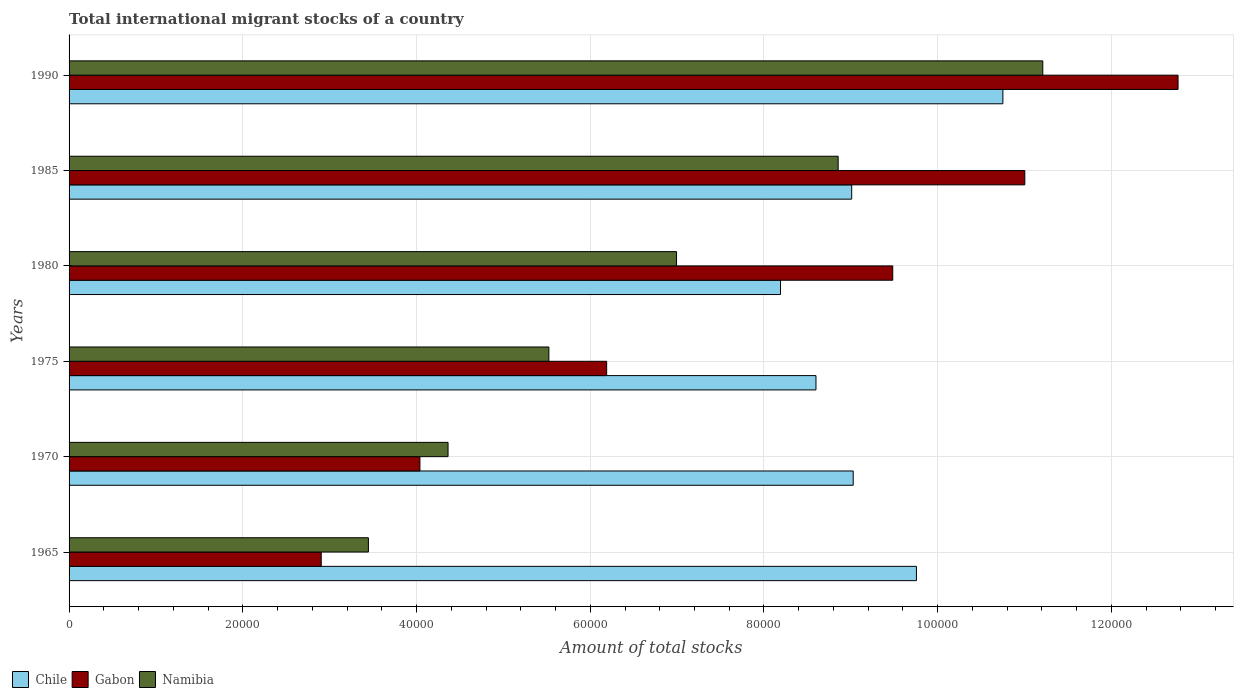How many different coloured bars are there?
Ensure brevity in your answer.  3. How many groups of bars are there?
Give a very brief answer. 6. Are the number of bars on each tick of the Y-axis equal?
Give a very brief answer. Yes. How many bars are there on the 2nd tick from the bottom?
Offer a terse response. 3. What is the label of the 4th group of bars from the top?
Make the answer very short. 1975. What is the amount of total stocks in in Chile in 1980?
Ensure brevity in your answer.  8.19e+04. Across all years, what is the maximum amount of total stocks in in Chile?
Your answer should be compact. 1.08e+05. Across all years, what is the minimum amount of total stocks in in Chile?
Ensure brevity in your answer.  8.19e+04. In which year was the amount of total stocks in in Namibia minimum?
Ensure brevity in your answer.  1965. What is the total amount of total stocks in in Namibia in the graph?
Ensure brevity in your answer.  4.04e+05. What is the difference between the amount of total stocks in in Namibia in 1970 and that in 1980?
Keep it short and to the point. -2.63e+04. What is the difference between the amount of total stocks in in Gabon in 1980 and the amount of total stocks in in Chile in 1985?
Ensure brevity in your answer.  4728. What is the average amount of total stocks in in Gabon per year?
Offer a very short reply. 7.73e+04. In the year 1970, what is the difference between the amount of total stocks in in Namibia and amount of total stocks in in Chile?
Your answer should be compact. -4.66e+04. What is the ratio of the amount of total stocks in in Namibia in 1965 to that in 1980?
Provide a succinct answer. 0.49. Is the amount of total stocks in in Namibia in 1970 less than that in 1975?
Keep it short and to the point. Yes. Is the difference between the amount of total stocks in in Namibia in 1975 and 1990 greater than the difference between the amount of total stocks in in Chile in 1975 and 1990?
Your response must be concise. No. What is the difference between the highest and the second highest amount of total stocks in in Chile?
Your answer should be very brief. 9950. What is the difference between the highest and the lowest amount of total stocks in in Gabon?
Offer a terse response. 9.86e+04. Is the sum of the amount of total stocks in in Chile in 1970 and 1975 greater than the maximum amount of total stocks in in Namibia across all years?
Offer a terse response. Yes. What does the 2nd bar from the top in 1970 represents?
Ensure brevity in your answer.  Gabon. Is it the case that in every year, the sum of the amount of total stocks in in Namibia and amount of total stocks in in Chile is greater than the amount of total stocks in in Gabon?
Offer a very short reply. Yes. How many bars are there?
Provide a succinct answer. 18. Are all the bars in the graph horizontal?
Your response must be concise. Yes. How many years are there in the graph?
Ensure brevity in your answer.  6. Are the values on the major ticks of X-axis written in scientific E-notation?
Give a very brief answer. No. Does the graph contain grids?
Your answer should be compact. Yes. What is the title of the graph?
Your answer should be very brief. Total international migrant stocks of a country. Does "Pacific island small states" appear as one of the legend labels in the graph?
Give a very brief answer. No. What is the label or title of the X-axis?
Provide a short and direct response. Amount of total stocks. What is the Amount of total stocks of Chile in 1965?
Ensure brevity in your answer.  9.76e+04. What is the Amount of total stocks in Gabon in 1965?
Give a very brief answer. 2.90e+04. What is the Amount of total stocks in Namibia in 1965?
Offer a very short reply. 3.45e+04. What is the Amount of total stocks in Chile in 1970?
Your answer should be compact. 9.03e+04. What is the Amount of total stocks of Gabon in 1970?
Provide a succinct answer. 4.04e+04. What is the Amount of total stocks in Namibia in 1970?
Offer a very short reply. 4.36e+04. What is the Amount of total stocks in Chile in 1975?
Ensure brevity in your answer.  8.60e+04. What is the Amount of total stocks in Gabon in 1975?
Provide a succinct answer. 6.19e+04. What is the Amount of total stocks in Namibia in 1975?
Offer a very short reply. 5.52e+04. What is the Amount of total stocks of Chile in 1980?
Give a very brief answer. 8.19e+04. What is the Amount of total stocks of Gabon in 1980?
Your response must be concise. 9.48e+04. What is the Amount of total stocks in Namibia in 1980?
Provide a short and direct response. 6.99e+04. What is the Amount of total stocks of Chile in 1985?
Your answer should be compact. 9.01e+04. What is the Amount of total stocks of Gabon in 1985?
Offer a very short reply. 1.10e+05. What is the Amount of total stocks of Namibia in 1985?
Provide a short and direct response. 8.85e+04. What is the Amount of total stocks of Chile in 1990?
Give a very brief answer. 1.08e+05. What is the Amount of total stocks in Gabon in 1990?
Your answer should be very brief. 1.28e+05. What is the Amount of total stocks in Namibia in 1990?
Your answer should be compact. 1.12e+05. Across all years, what is the maximum Amount of total stocks of Chile?
Make the answer very short. 1.08e+05. Across all years, what is the maximum Amount of total stocks in Gabon?
Your answer should be very brief. 1.28e+05. Across all years, what is the maximum Amount of total stocks in Namibia?
Make the answer very short. 1.12e+05. Across all years, what is the minimum Amount of total stocks in Chile?
Give a very brief answer. 8.19e+04. Across all years, what is the minimum Amount of total stocks of Gabon?
Your answer should be compact. 2.90e+04. Across all years, what is the minimum Amount of total stocks in Namibia?
Your response must be concise. 3.45e+04. What is the total Amount of total stocks of Chile in the graph?
Keep it short and to the point. 5.53e+05. What is the total Amount of total stocks of Gabon in the graph?
Make the answer very short. 4.64e+05. What is the total Amount of total stocks in Namibia in the graph?
Ensure brevity in your answer.  4.04e+05. What is the difference between the Amount of total stocks of Chile in 1965 and that in 1970?
Provide a short and direct response. 7280. What is the difference between the Amount of total stocks in Gabon in 1965 and that in 1970?
Your answer should be very brief. -1.14e+04. What is the difference between the Amount of total stocks of Namibia in 1965 and that in 1970?
Your answer should be very brief. -9168. What is the difference between the Amount of total stocks in Chile in 1965 and that in 1975?
Make the answer very short. 1.16e+04. What is the difference between the Amount of total stocks in Gabon in 1965 and that in 1975?
Your response must be concise. -3.29e+04. What is the difference between the Amount of total stocks of Namibia in 1965 and that in 1975?
Give a very brief answer. -2.08e+04. What is the difference between the Amount of total stocks in Chile in 1965 and that in 1980?
Your answer should be very brief. 1.56e+04. What is the difference between the Amount of total stocks in Gabon in 1965 and that in 1980?
Keep it short and to the point. -6.58e+04. What is the difference between the Amount of total stocks of Namibia in 1965 and that in 1980?
Offer a very short reply. -3.55e+04. What is the difference between the Amount of total stocks of Chile in 1965 and that in 1985?
Give a very brief answer. 7455. What is the difference between the Amount of total stocks of Gabon in 1965 and that in 1985?
Make the answer very short. -8.10e+04. What is the difference between the Amount of total stocks of Namibia in 1965 and that in 1985?
Provide a short and direct response. -5.41e+04. What is the difference between the Amount of total stocks in Chile in 1965 and that in 1990?
Your response must be concise. -9950. What is the difference between the Amount of total stocks of Gabon in 1965 and that in 1990?
Offer a very short reply. -9.86e+04. What is the difference between the Amount of total stocks in Namibia in 1965 and that in 1990?
Ensure brevity in your answer.  -7.76e+04. What is the difference between the Amount of total stocks of Chile in 1970 and that in 1975?
Your response must be concise. 4286. What is the difference between the Amount of total stocks of Gabon in 1970 and that in 1975?
Your answer should be compact. -2.15e+04. What is the difference between the Amount of total stocks in Namibia in 1970 and that in 1975?
Your response must be concise. -1.16e+04. What is the difference between the Amount of total stocks of Chile in 1970 and that in 1980?
Ensure brevity in your answer.  8368. What is the difference between the Amount of total stocks of Gabon in 1970 and that in 1980?
Keep it short and to the point. -5.44e+04. What is the difference between the Amount of total stocks in Namibia in 1970 and that in 1980?
Offer a very short reply. -2.63e+04. What is the difference between the Amount of total stocks of Chile in 1970 and that in 1985?
Provide a succinct answer. 175. What is the difference between the Amount of total stocks in Gabon in 1970 and that in 1985?
Give a very brief answer. -6.96e+04. What is the difference between the Amount of total stocks of Namibia in 1970 and that in 1985?
Keep it short and to the point. -4.49e+04. What is the difference between the Amount of total stocks in Chile in 1970 and that in 1990?
Your response must be concise. -1.72e+04. What is the difference between the Amount of total stocks of Gabon in 1970 and that in 1990?
Ensure brevity in your answer.  -8.73e+04. What is the difference between the Amount of total stocks in Namibia in 1970 and that in 1990?
Give a very brief answer. -6.85e+04. What is the difference between the Amount of total stocks of Chile in 1975 and that in 1980?
Your response must be concise. 4082. What is the difference between the Amount of total stocks in Gabon in 1975 and that in 1980?
Make the answer very short. -3.29e+04. What is the difference between the Amount of total stocks of Namibia in 1975 and that in 1980?
Offer a very short reply. -1.47e+04. What is the difference between the Amount of total stocks in Chile in 1975 and that in 1985?
Your response must be concise. -4111. What is the difference between the Amount of total stocks of Gabon in 1975 and that in 1985?
Offer a very short reply. -4.81e+04. What is the difference between the Amount of total stocks of Namibia in 1975 and that in 1985?
Give a very brief answer. -3.33e+04. What is the difference between the Amount of total stocks in Chile in 1975 and that in 1990?
Offer a terse response. -2.15e+04. What is the difference between the Amount of total stocks of Gabon in 1975 and that in 1990?
Offer a very short reply. -6.58e+04. What is the difference between the Amount of total stocks of Namibia in 1975 and that in 1990?
Provide a succinct answer. -5.69e+04. What is the difference between the Amount of total stocks in Chile in 1980 and that in 1985?
Provide a succinct answer. -8193. What is the difference between the Amount of total stocks in Gabon in 1980 and that in 1985?
Ensure brevity in your answer.  -1.52e+04. What is the difference between the Amount of total stocks of Namibia in 1980 and that in 1985?
Your answer should be compact. -1.86e+04. What is the difference between the Amount of total stocks of Chile in 1980 and that in 1990?
Make the answer very short. -2.56e+04. What is the difference between the Amount of total stocks of Gabon in 1980 and that in 1990?
Offer a terse response. -3.28e+04. What is the difference between the Amount of total stocks of Namibia in 1980 and that in 1990?
Your response must be concise. -4.22e+04. What is the difference between the Amount of total stocks in Chile in 1985 and that in 1990?
Your response must be concise. -1.74e+04. What is the difference between the Amount of total stocks in Gabon in 1985 and that in 1990?
Provide a succinct answer. -1.76e+04. What is the difference between the Amount of total stocks of Namibia in 1985 and that in 1990?
Offer a terse response. -2.36e+04. What is the difference between the Amount of total stocks in Chile in 1965 and the Amount of total stocks in Gabon in 1970?
Provide a succinct answer. 5.72e+04. What is the difference between the Amount of total stocks in Chile in 1965 and the Amount of total stocks in Namibia in 1970?
Your answer should be very brief. 5.39e+04. What is the difference between the Amount of total stocks in Gabon in 1965 and the Amount of total stocks in Namibia in 1970?
Keep it short and to the point. -1.46e+04. What is the difference between the Amount of total stocks of Chile in 1965 and the Amount of total stocks of Gabon in 1975?
Give a very brief answer. 3.57e+04. What is the difference between the Amount of total stocks of Chile in 1965 and the Amount of total stocks of Namibia in 1975?
Make the answer very short. 4.23e+04. What is the difference between the Amount of total stocks of Gabon in 1965 and the Amount of total stocks of Namibia in 1975?
Offer a terse response. -2.62e+04. What is the difference between the Amount of total stocks in Chile in 1965 and the Amount of total stocks in Gabon in 1980?
Your answer should be very brief. 2727. What is the difference between the Amount of total stocks of Chile in 1965 and the Amount of total stocks of Namibia in 1980?
Offer a terse response. 2.76e+04. What is the difference between the Amount of total stocks of Gabon in 1965 and the Amount of total stocks of Namibia in 1980?
Give a very brief answer. -4.09e+04. What is the difference between the Amount of total stocks of Chile in 1965 and the Amount of total stocks of Gabon in 1985?
Give a very brief answer. -1.25e+04. What is the difference between the Amount of total stocks of Chile in 1965 and the Amount of total stocks of Namibia in 1985?
Your answer should be compact. 9012. What is the difference between the Amount of total stocks in Gabon in 1965 and the Amount of total stocks in Namibia in 1985?
Offer a terse response. -5.95e+04. What is the difference between the Amount of total stocks in Chile in 1965 and the Amount of total stocks in Gabon in 1990?
Give a very brief answer. -3.01e+04. What is the difference between the Amount of total stocks in Chile in 1965 and the Amount of total stocks in Namibia in 1990?
Offer a terse response. -1.45e+04. What is the difference between the Amount of total stocks of Gabon in 1965 and the Amount of total stocks of Namibia in 1990?
Make the answer very short. -8.31e+04. What is the difference between the Amount of total stocks in Chile in 1970 and the Amount of total stocks in Gabon in 1975?
Offer a terse response. 2.84e+04. What is the difference between the Amount of total stocks in Chile in 1970 and the Amount of total stocks in Namibia in 1975?
Offer a very short reply. 3.50e+04. What is the difference between the Amount of total stocks of Gabon in 1970 and the Amount of total stocks of Namibia in 1975?
Ensure brevity in your answer.  -1.48e+04. What is the difference between the Amount of total stocks of Chile in 1970 and the Amount of total stocks of Gabon in 1980?
Offer a very short reply. -4553. What is the difference between the Amount of total stocks of Chile in 1970 and the Amount of total stocks of Namibia in 1980?
Offer a very short reply. 2.03e+04. What is the difference between the Amount of total stocks in Gabon in 1970 and the Amount of total stocks in Namibia in 1980?
Your answer should be compact. -2.95e+04. What is the difference between the Amount of total stocks of Chile in 1970 and the Amount of total stocks of Gabon in 1985?
Your answer should be compact. -1.98e+04. What is the difference between the Amount of total stocks of Chile in 1970 and the Amount of total stocks of Namibia in 1985?
Provide a succinct answer. 1732. What is the difference between the Amount of total stocks in Gabon in 1970 and the Amount of total stocks in Namibia in 1985?
Keep it short and to the point. -4.81e+04. What is the difference between the Amount of total stocks in Chile in 1970 and the Amount of total stocks in Gabon in 1990?
Your response must be concise. -3.74e+04. What is the difference between the Amount of total stocks in Chile in 1970 and the Amount of total stocks in Namibia in 1990?
Provide a succinct answer. -2.18e+04. What is the difference between the Amount of total stocks of Gabon in 1970 and the Amount of total stocks of Namibia in 1990?
Make the answer very short. -7.17e+04. What is the difference between the Amount of total stocks of Chile in 1975 and the Amount of total stocks of Gabon in 1980?
Your answer should be compact. -8839. What is the difference between the Amount of total stocks in Chile in 1975 and the Amount of total stocks in Namibia in 1980?
Make the answer very short. 1.61e+04. What is the difference between the Amount of total stocks of Gabon in 1975 and the Amount of total stocks of Namibia in 1980?
Provide a short and direct response. -8045. What is the difference between the Amount of total stocks of Chile in 1975 and the Amount of total stocks of Gabon in 1985?
Provide a short and direct response. -2.40e+04. What is the difference between the Amount of total stocks in Chile in 1975 and the Amount of total stocks in Namibia in 1985?
Make the answer very short. -2554. What is the difference between the Amount of total stocks in Gabon in 1975 and the Amount of total stocks in Namibia in 1985?
Offer a terse response. -2.67e+04. What is the difference between the Amount of total stocks of Chile in 1975 and the Amount of total stocks of Gabon in 1990?
Your response must be concise. -4.17e+04. What is the difference between the Amount of total stocks in Chile in 1975 and the Amount of total stocks in Namibia in 1990?
Make the answer very short. -2.61e+04. What is the difference between the Amount of total stocks in Gabon in 1975 and the Amount of total stocks in Namibia in 1990?
Make the answer very short. -5.02e+04. What is the difference between the Amount of total stocks in Chile in 1980 and the Amount of total stocks in Gabon in 1985?
Ensure brevity in your answer.  -2.81e+04. What is the difference between the Amount of total stocks in Chile in 1980 and the Amount of total stocks in Namibia in 1985?
Provide a succinct answer. -6636. What is the difference between the Amount of total stocks of Gabon in 1980 and the Amount of total stocks of Namibia in 1985?
Give a very brief answer. 6285. What is the difference between the Amount of total stocks of Chile in 1980 and the Amount of total stocks of Gabon in 1990?
Give a very brief answer. -4.58e+04. What is the difference between the Amount of total stocks in Chile in 1980 and the Amount of total stocks in Namibia in 1990?
Offer a terse response. -3.02e+04. What is the difference between the Amount of total stocks of Gabon in 1980 and the Amount of total stocks of Namibia in 1990?
Ensure brevity in your answer.  -1.73e+04. What is the difference between the Amount of total stocks in Chile in 1985 and the Amount of total stocks in Gabon in 1990?
Keep it short and to the point. -3.76e+04. What is the difference between the Amount of total stocks in Chile in 1985 and the Amount of total stocks in Namibia in 1990?
Keep it short and to the point. -2.20e+04. What is the difference between the Amount of total stocks in Gabon in 1985 and the Amount of total stocks in Namibia in 1990?
Give a very brief answer. -2069. What is the average Amount of total stocks in Chile per year?
Provide a short and direct response. 9.22e+04. What is the average Amount of total stocks in Gabon per year?
Give a very brief answer. 7.73e+04. What is the average Amount of total stocks of Namibia per year?
Your answer should be very brief. 6.73e+04. In the year 1965, what is the difference between the Amount of total stocks of Chile and Amount of total stocks of Gabon?
Offer a very short reply. 6.85e+04. In the year 1965, what is the difference between the Amount of total stocks of Chile and Amount of total stocks of Namibia?
Provide a short and direct response. 6.31e+04. In the year 1965, what is the difference between the Amount of total stocks in Gabon and Amount of total stocks in Namibia?
Offer a very short reply. -5430. In the year 1970, what is the difference between the Amount of total stocks in Chile and Amount of total stocks in Gabon?
Offer a very short reply. 4.99e+04. In the year 1970, what is the difference between the Amount of total stocks in Chile and Amount of total stocks in Namibia?
Make the answer very short. 4.66e+04. In the year 1970, what is the difference between the Amount of total stocks in Gabon and Amount of total stocks in Namibia?
Offer a terse response. -3237. In the year 1975, what is the difference between the Amount of total stocks in Chile and Amount of total stocks in Gabon?
Keep it short and to the point. 2.41e+04. In the year 1975, what is the difference between the Amount of total stocks of Chile and Amount of total stocks of Namibia?
Ensure brevity in your answer.  3.07e+04. In the year 1975, what is the difference between the Amount of total stocks in Gabon and Amount of total stocks in Namibia?
Your response must be concise. 6651. In the year 1980, what is the difference between the Amount of total stocks in Chile and Amount of total stocks in Gabon?
Offer a very short reply. -1.29e+04. In the year 1980, what is the difference between the Amount of total stocks of Chile and Amount of total stocks of Namibia?
Keep it short and to the point. 1.20e+04. In the year 1980, what is the difference between the Amount of total stocks in Gabon and Amount of total stocks in Namibia?
Ensure brevity in your answer.  2.49e+04. In the year 1985, what is the difference between the Amount of total stocks of Chile and Amount of total stocks of Gabon?
Provide a succinct answer. -1.99e+04. In the year 1985, what is the difference between the Amount of total stocks in Chile and Amount of total stocks in Namibia?
Offer a very short reply. 1557. In the year 1985, what is the difference between the Amount of total stocks of Gabon and Amount of total stocks of Namibia?
Keep it short and to the point. 2.15e+04. In the year 1990, what is the difference between the Amount of total stocks in Chile and Amount of total stocks in Gabon?
Give a very brief answer. -2.02e+04. In the year 1990, what is the difference between the Amount of total stocks of Chile and Amount of total stocks of Namibia?
Offer a terse response. -4595. In the year 1990, what is the difference between the Amount of total stocks in Gabon and Amount of total stocks in Namibia?
Make the answer very short. 1.56e+04. What is the ratio of the Amount of total stocks of Chile in 1965 to that in 1970?
Provide a succinct answer. 1.08. What is the ratio of the Amount of total stocks in Gabon in 1965 to that in 1970?
Make the answer very short. 0.72. What is the ratio of the Amount of total stocks of Namibia in 1965 to that in 1970?
Give a very brief answer. 0.79. What is the ratio of the Amount of total stocks of Chile in 1965 to that in 1975?
Ensure brevity in your answer.  1.13. What is the ratio of the Amount of total stocks in Gabon in 1965 to that in 1975?
Provide a short and direct response. 0.47. What is the ratio of the Amount of total stocks of Namibia in 1965 to that in 1975?
Your response must be concise. 0.62. What is the ratio of the Amount of total stocks in Chile in 1965 to that in 1980?
Your response must be concise. 1.19. What is the ratio of the Amount of total stocks of Gabon in 1965 to that in 1980?
Offer a very short reply. 0.31. What is the ratio of the Amount of total stocks of Namibia in 1965 to that in 1980?
Ensure brevity in your answer.  0.49. What is the ratio of the Amount of total stocks of Chile in 1965 to that in 1985?
Your answer should be compact. 1.08. What is the ratio of the Amount of total stocks of Gabon in 1965 to that in 1985?
Provide a succinct answer. 0.26. What is the ratio of the Amount of total stocks of Namibia in 1965 to that in 1985?
Offer a very short reply. 0.39. What is the ratio of the Amount of total stocks in Chile in 1965 to that in 1990?
Ensure brevity in your answer.  0.91. What is the ratio of the Amount of total stocks of Gabon in 1965 to that in 1990?
Give a very brief answer. 0.23. What is the ratio of the Amount of total stocks of Namibia in 1965 to that in 1990?
Ensure brevity in your answer.  0.31. What is the ratio of the Amount of total stocks of Chile in 1970 to that in 1975?
Offer a very short reply. 1.05. What is the ratio of the Amount of total stocks in Gabon in 1970 to that in 1975?
Your answer should be very brief. 0.65. What is the ratio of the Amount of total stocks of Namibia in 1970 to that in 1975?
Your answer should be compact. 0.79. What is the ratio of the Amount of total stocks in Chile in 1970 to that in 1980?
Give a very brief answer. 1.1. What is the ratio of the Amount of total stocks of Gabon in 1970 to that in 1980?
Your answer should be very brief. 0.43. What is the ratio of the Amount of total stocks of Namibia in 1970 to that in 1980?
Provide a short and direct response. 0.62. What is the ratio of the Amount of total stocks in Chile in 1970 to that in 1985?
Offer a very short reply. 1. What is the ratio of the Amount of total stocks in Gabon in 1970 to that in 1985?
Provide a short and direct response. 0.37. What is the ratio of the Amount of total stocks of Namibia in 1970 to that in 1985?
Provide a short and direct response. 0.49. What is the ratio of the Amount of total stocks in Chile in 1970 to that in 1990?
Provide a succinct answer. 0.84. What is the ratio of the Amount of total stocks of Gabon in 1970 to that in 1990?
Keep it short and to the point. 0.32. What is the ratio of the Amount of total stocks of Namibia in 1970 to that in 1990?
Give a very brief answer. 0.39. What is the ratio of the Amount of total stocks of Chile in 1975 to that in 1980?
Your response must be concise. 1.05. What is the ratio of the Amount of total stocks in Gabon in 1975 to that in 1980?
Provide a short and direct response. 0.65. What is the ratio of the Amount of total stocks of Namibia in 1975 to that in 1980?
Provide a succinct answer. 0.79. What is the ratio of the Amount of total stocks of Chile in 1975 to that in 1985?
Your response must be concise. 0.95. What is the ratio of the Amount of total stocks in Gabon in 1975 to that in 1985?
Provide a succinct answer. 0.56. What is the ratio of the Amount of total stocks of Namibia in 1975 to that in 1985?
Offer a very short reply. 0.62. What is the ratio of the Amount of total stocks of Chile in 1975 to that in 1990?
Offer a very short reply. 0.8. What is the ratio of the Amount of total stocks of Gabon in 1975 to that in 1990?
Offer a terse response. 0.48. What is the ratio of the Amount of total stocks in Namibia in 1975 to that in 1990?
Offer a terse response. 0.49. What is the ratio of the Amount of total stocks in Gabon in 1980 to that in 1985?
Provide a short and direct response. 0.86. What is the ratio of the Amount of total stocks in Namibia in 1980 to that in 1985?
Your answer should be compact. 0.79. What is the ratio of the Amount of total stocks of Chile in 1980 to that in 1990?
Your response must be concise. 0.76. What is the ratio of the Amount of total stocks of Gabon in 1980 to that in 1990?
Your answer should be compact. 0.74. What is the ratio of the Amount of total stocks of Namibia in 1980 to that in 1990?
Give a very brief answer. 0.62. What is the ratio of the Amount of total stocks in Chile in 1985 to that in 1990?
Offer a terse response. 0.84. What is the ratio of the Amount of total stocks in Gabon in 1985 to that in 1990?
Make the answer very short. 0.86. What is the ratio of the Amount of total stocks in Namibia in 1985 to that in 1990?
Your response must be concise. 0.79. What is the difference between the highest and the second highest Amount of total stocks of Chile?
Offer a very short reply. 9950. What is the difference between the highest and the second highest Amount of total stocks of Gabon?
Ensure brevity in your answer.  1.76e+04. What is the difference between the highest and the second highest Amount of total stocks of Namibia?
Ensure brevity in your answer.  2.36e+04. What is the difference between the highest and the lowest Amount of total stocks in Chile?
Your response must be concise. 2.56e+04. What is the difference between the highest and the lowest Amount of total stocks in Gabon?
Offer a very short reply. 9.86e+04. What is the difference between the highest and the lowest Amount of total stocks in Namibia?
Provide a succinct answer. 7.76e+04. 